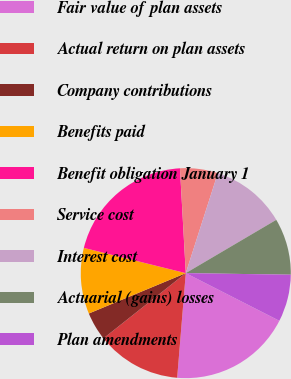Convert chart. <chart><loc_0><loc_0><loc_500><loc_500><pie_chart><fcel>Fair value of plan assets<fcel>Actual return on plan assets<fcel>Company contributions<fcel>Benefits paid<fcel>Benefit obligation January 1<fcel>Service cost<fcel>Interest cost<fcel>Actuarial (gains) losses<fcel>Plan amendments<nl><fcel>18.81%<fcel>13.03%<fcel>4.38%<fcel>10.15%<fcel>20.25%<fcel>5.82%<fcel>11.59%<fcel>8.71%<fcel>7.26%<nl></chart> 